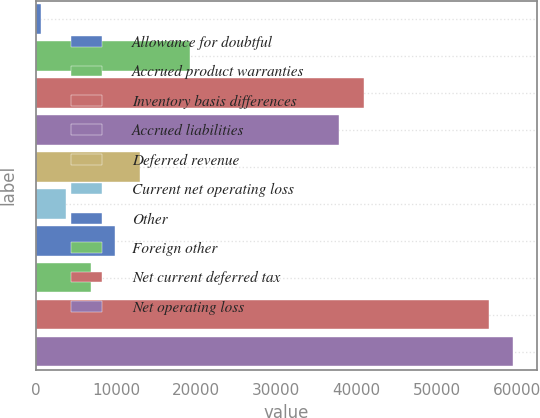Convert chart. <chart><loc_0><loc_0><loc_500><loc_500><bar_chart><fcel>Allowance for doubtful<fcel>Accrued product warranties<fcel>Inventory basis differences<fcel>Accrued liabilities<fcel>Deferred revenue<fcel>Current net operating loss<fcel>Other<fcel>Foreign other<fcel>Net current deferred tax<fcel>Net operating loss<nl><fcel>595<fcel>19223.8<fcel>40957.4<fcel>37852.6<fcel>13014.2<fcel>3699.8<fcel>9909.4<fcel>6804.6<fcel>56481.4<fcel>59586.2<nl></chart> 